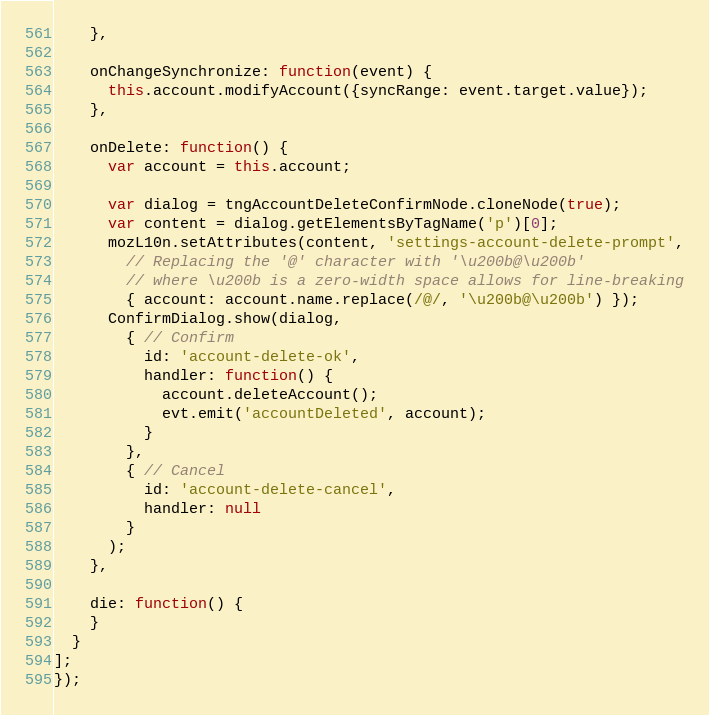Convert code to text. <code><loc_0><loc_0><loc_500><loc_500><_JavaScript_>    },

    onChangeSynchronize: function(event) {
      this.account.modifyAccount({syncRange: event.target.value});
    },

    onDelete: function() {
      var account = this.account;

      var dialog = tngAccountDeleteConfirmNode.cloneNode(true);
      var content = dialog.getElementsByTagName('p')[0];
      mozL10n.setAttributes(content, 'settings-account-delete-prompt',
        // Replacing the '@' character with '\u200b@\u200b'
        // where \u200b is a zero-width space allows for line-breaking
        { account: account.name.replace(/@/, '\u200b@\u200b') });
      ConfirmDialog.show(dialog,
        { // Confirm
          id: 'account-delete-ok',
          handler: function() {
            account.deleteAccount();
            evt.emit('accountDeleted', account);
          }
        },
        { // Cancel
          id: 'account-delete-cancel',
          handler: null
        }
      );
    },

    die: function() {
    }
  }
];
});
</code> 